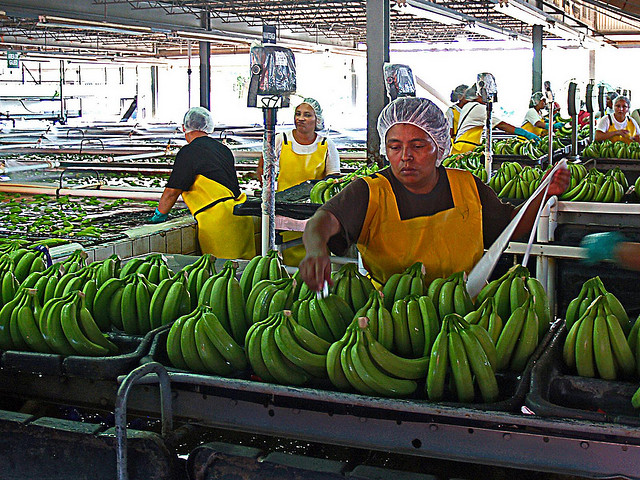What does the hair cap prevent?
A. dandruff
B. stray hairs
C. distraction
D. flies The hair cap is primarily designed to prevent stray hairs from falling into places where cleanliness and hygiene are paramount, such as in food processing facilities, as depicted in the image. By wearing these caps, workers ensure that their hair does not contaminate the products, which in this case, are bunches of bananas being prepared for distribution. 